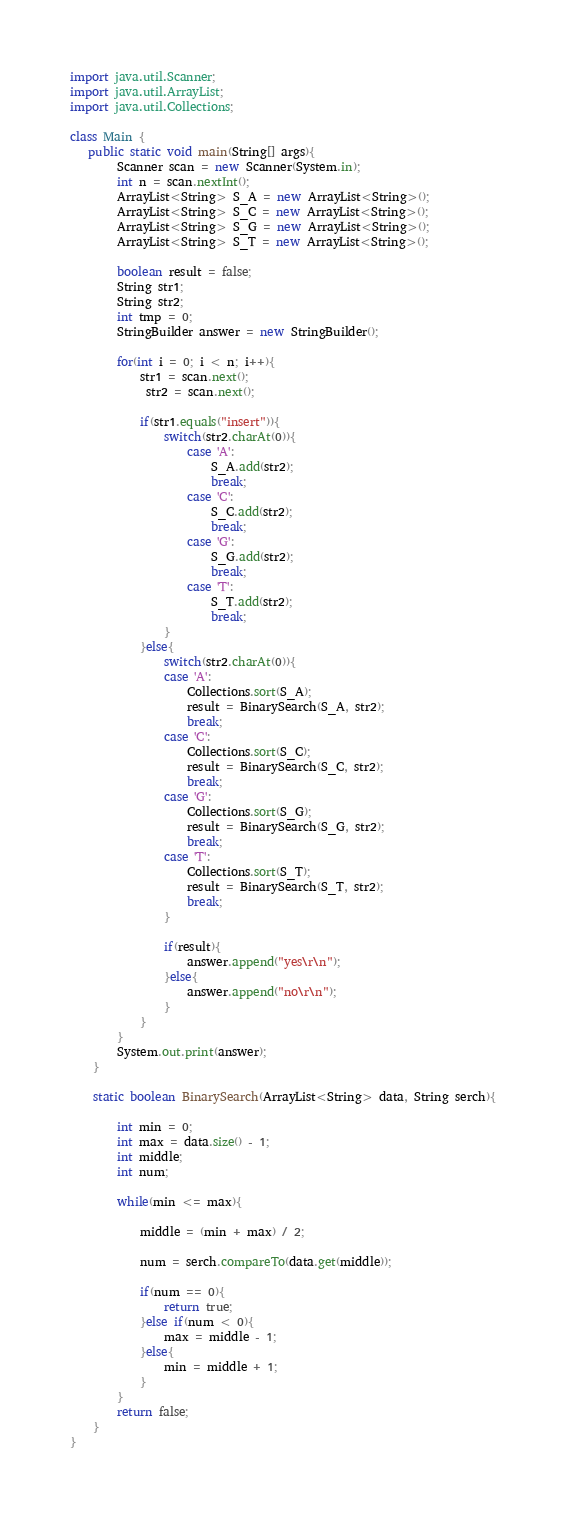<code> <loc_0><loc_0><loc_500><loc_500><_Java_>import java.util.Scanner;
import java.util.ArrayList;
import java.util.Collections;

class Main {
   public static void main(String[] args){
		Scanner scan = new Scanner(System.in);
		int n = scan.nextInt();
		ArrayList<String> S_A = new ArrayList<String>();
		ArrayList<String> S_C = new ArrayList<String>();
		ArrayList<String> S_G = new ArrayList<String>();
		ArrayList<String> S_T = new ArrayList<String>();

		boolean result = false;
		String str1;
		String str2;
		int tmp = 0;
		StringBuilder answer = new StringBuilder();

		for(int i = 0; i < n; i++){
			str1 = scan.next();
			 str2 = scan.next();

			if(str1.equals("insert")){
				switch(str2.charAt(0)){
					case 'A':
						S_A.add(str2);
						break;
					case 'C':
						S_C.add(str2);
						break;
					case 'G':
						S_G.add(str2);
						break;
					case 'T':
						S_T.add(str2);
						break;
				}
			}else{
				switch(str2.charAt(0)){
				case 'A':
					Collections.sort(S_A);
					result = BinarySearch(S_A, str2);
					break;
				case 'C':
					Collections.sort(S_C);
					result = BinarySearch(S_C, str2);
					break;
				case 'G':
					Collections.sort(S_G);
					result = BinarySearch(S_G, str2);
					break;
				case 'T':
					Collections.sort(S_T);
					result = BinarySearch(S_T, str2);
					break;
				}
				
				if(result){
					answer.append("yes\r\n");
				}else{
					answer.append("no\r\n");
				}
			}
		}
		System.out.print(answer);
	}

	static boolean BinarySearch(ArrayList<String> data, String serch){

		int min = 0;
		int max = data.size() - 1;
		int middle;
		int num;

		while(min <= max){

			middle = (min + max) / 2;
			
			num = serch.compareTo(data.get(middle));

			if(num == 0){
				return true;
			}else if(num < 0){
				max = middle - 1;
			}else{
				min = middle + 1;
			}
		}
		return false;
	}
}</code> 